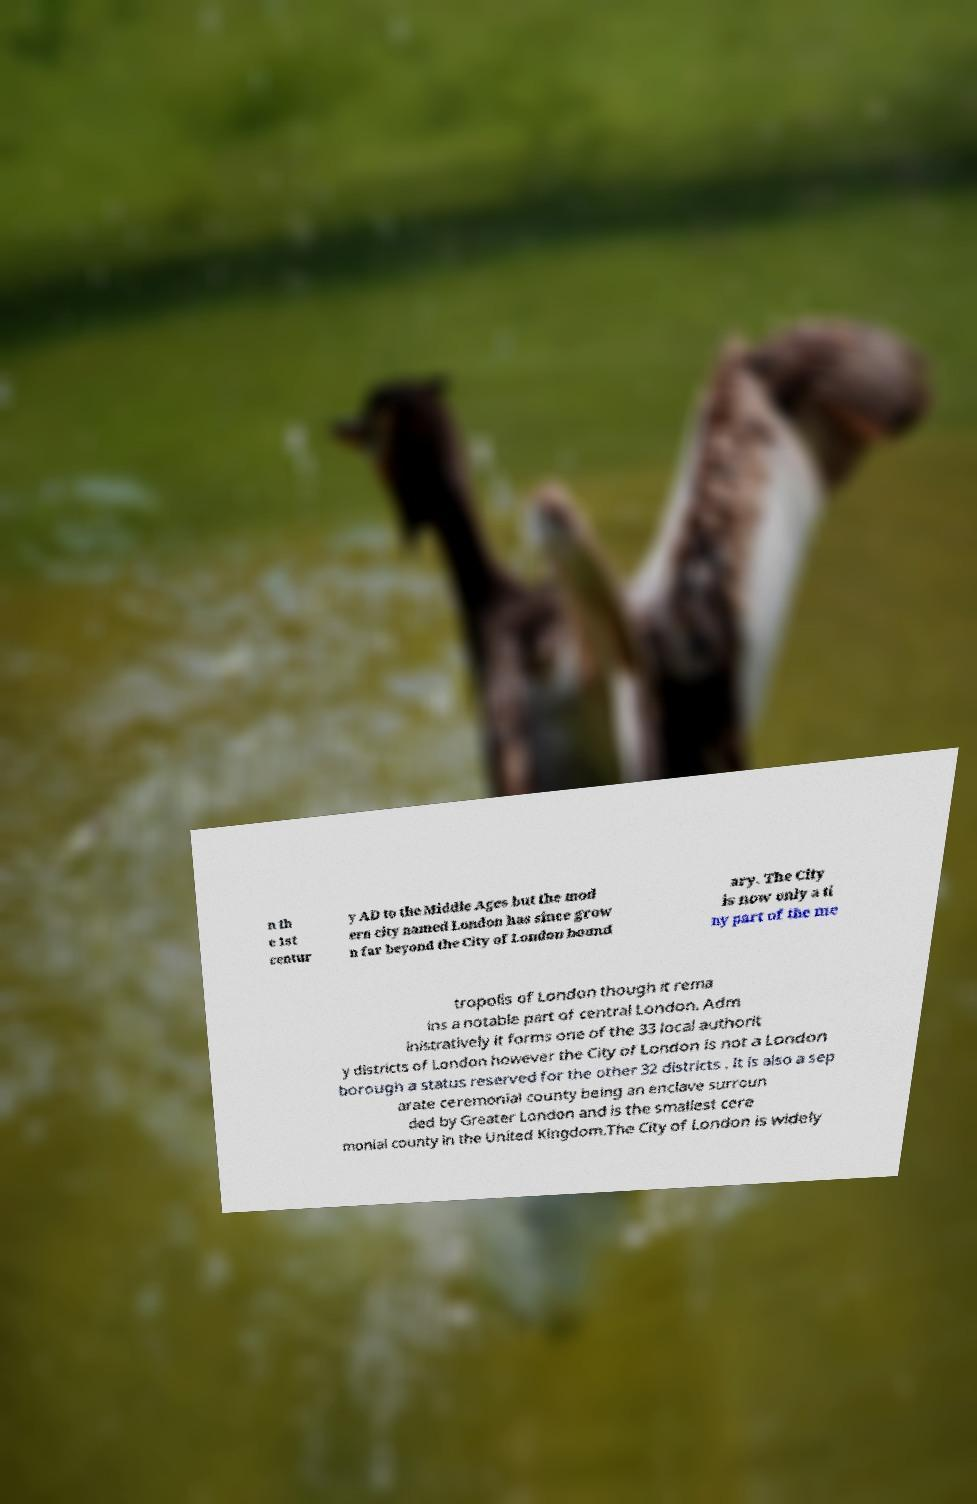I need the written content from this picture converted into text. Can you do that? n th e 1st centur y AD to the Middle Ages but the mod ern city named London has since grow n far beyond the City of London bound ary. The City is now only a ti ny part of the me tropolis of London though it rema ins a notable part of central London. Adm inistratively it forms one of the 33 local authorit y districts of London however the City of London is not a London borough a status reserved for the other 32 districts . It is also a sep arate ceremonial county being an enclave surroun ded by Greater London and is the smallest cere monial county in the United Kingdom.The City of London is widely 